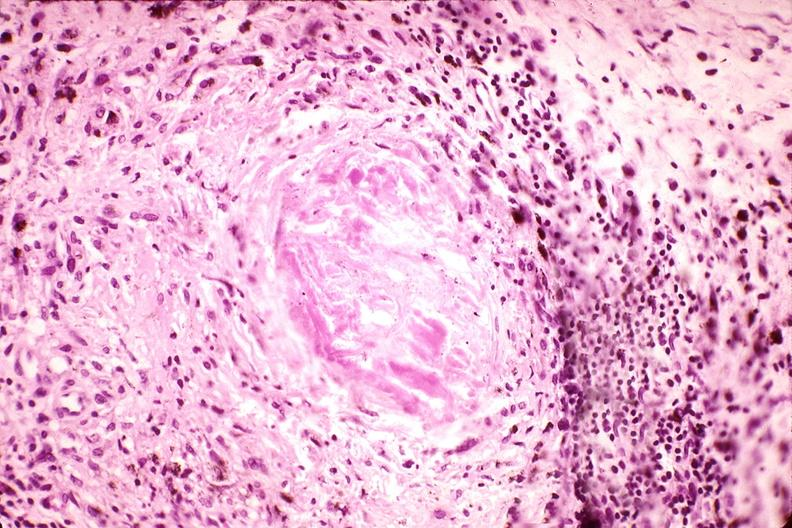s mucoepidermoid carcinoma present?
Answer the question using a single word or phrase. No 